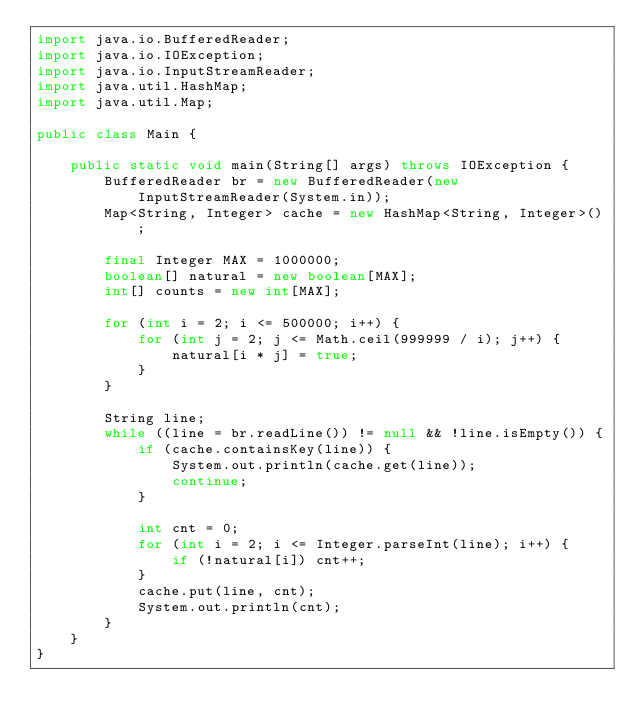Convert code to text. <code><loc_0><loc_0><loc_500><loc_500><_Java_>import java.io.BufferedReader;
import java.io.IOException;
import java.io.InputStreamReader;
import java.util.HashMap;
import java.util.Map;

public class Main {

    public static void main(String[] args) throws IOException {
        BufferedReader br = new BufferedReader(new InputStreamReader(System.in));
        Map<String, Integer> cache = new HashMap<String, Integer>();

        final Integer MAX = 1000000;
        boolean[] natural = new boolean[MAX];
        int[] counts = new int[MAX];

        for (int i = 2; i <= 500000; i++) {
            for (int j = 2; j <= Math.ceil(999999 / i); j++) {
                natural[i * j] = true;
            }
        }

        String line;
        while ((line = br.readLine()) != null && !line.isEmpty()) {
            if (cache.containsKey(line)) {
                System.out.println(cache.get(line));
                continue;
            }

            int cnt = 0;
            for (int i = 2; i <= Integer.parseInt(line); i++) {
                if (!natural[i]) cnt++;
            }
            cache.put(line, cnt);
            System.out.println(cnt);
        }
    }
}</code> 